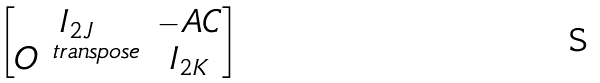<formula> <loc_0><loc_0><loc_500><loc_500>\begin{bmatrix} I _ { 2 J } & - A C \\ O ^ { \ t r a n s p o s e } & I _ { 2 K } \end{bmatrix}</formula> 